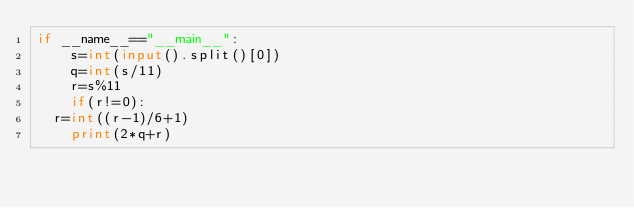Convert code to text. <code><loc_0><loc_0><loc_500><loc_500><_Python_>if __name__=="__main__":
    s=int(input().split()[0])
    q=int(s/11)
    r=s%11
    if(r!=0):
	r=int((r-1)/6+1)
    print(2*q+r)</code> 